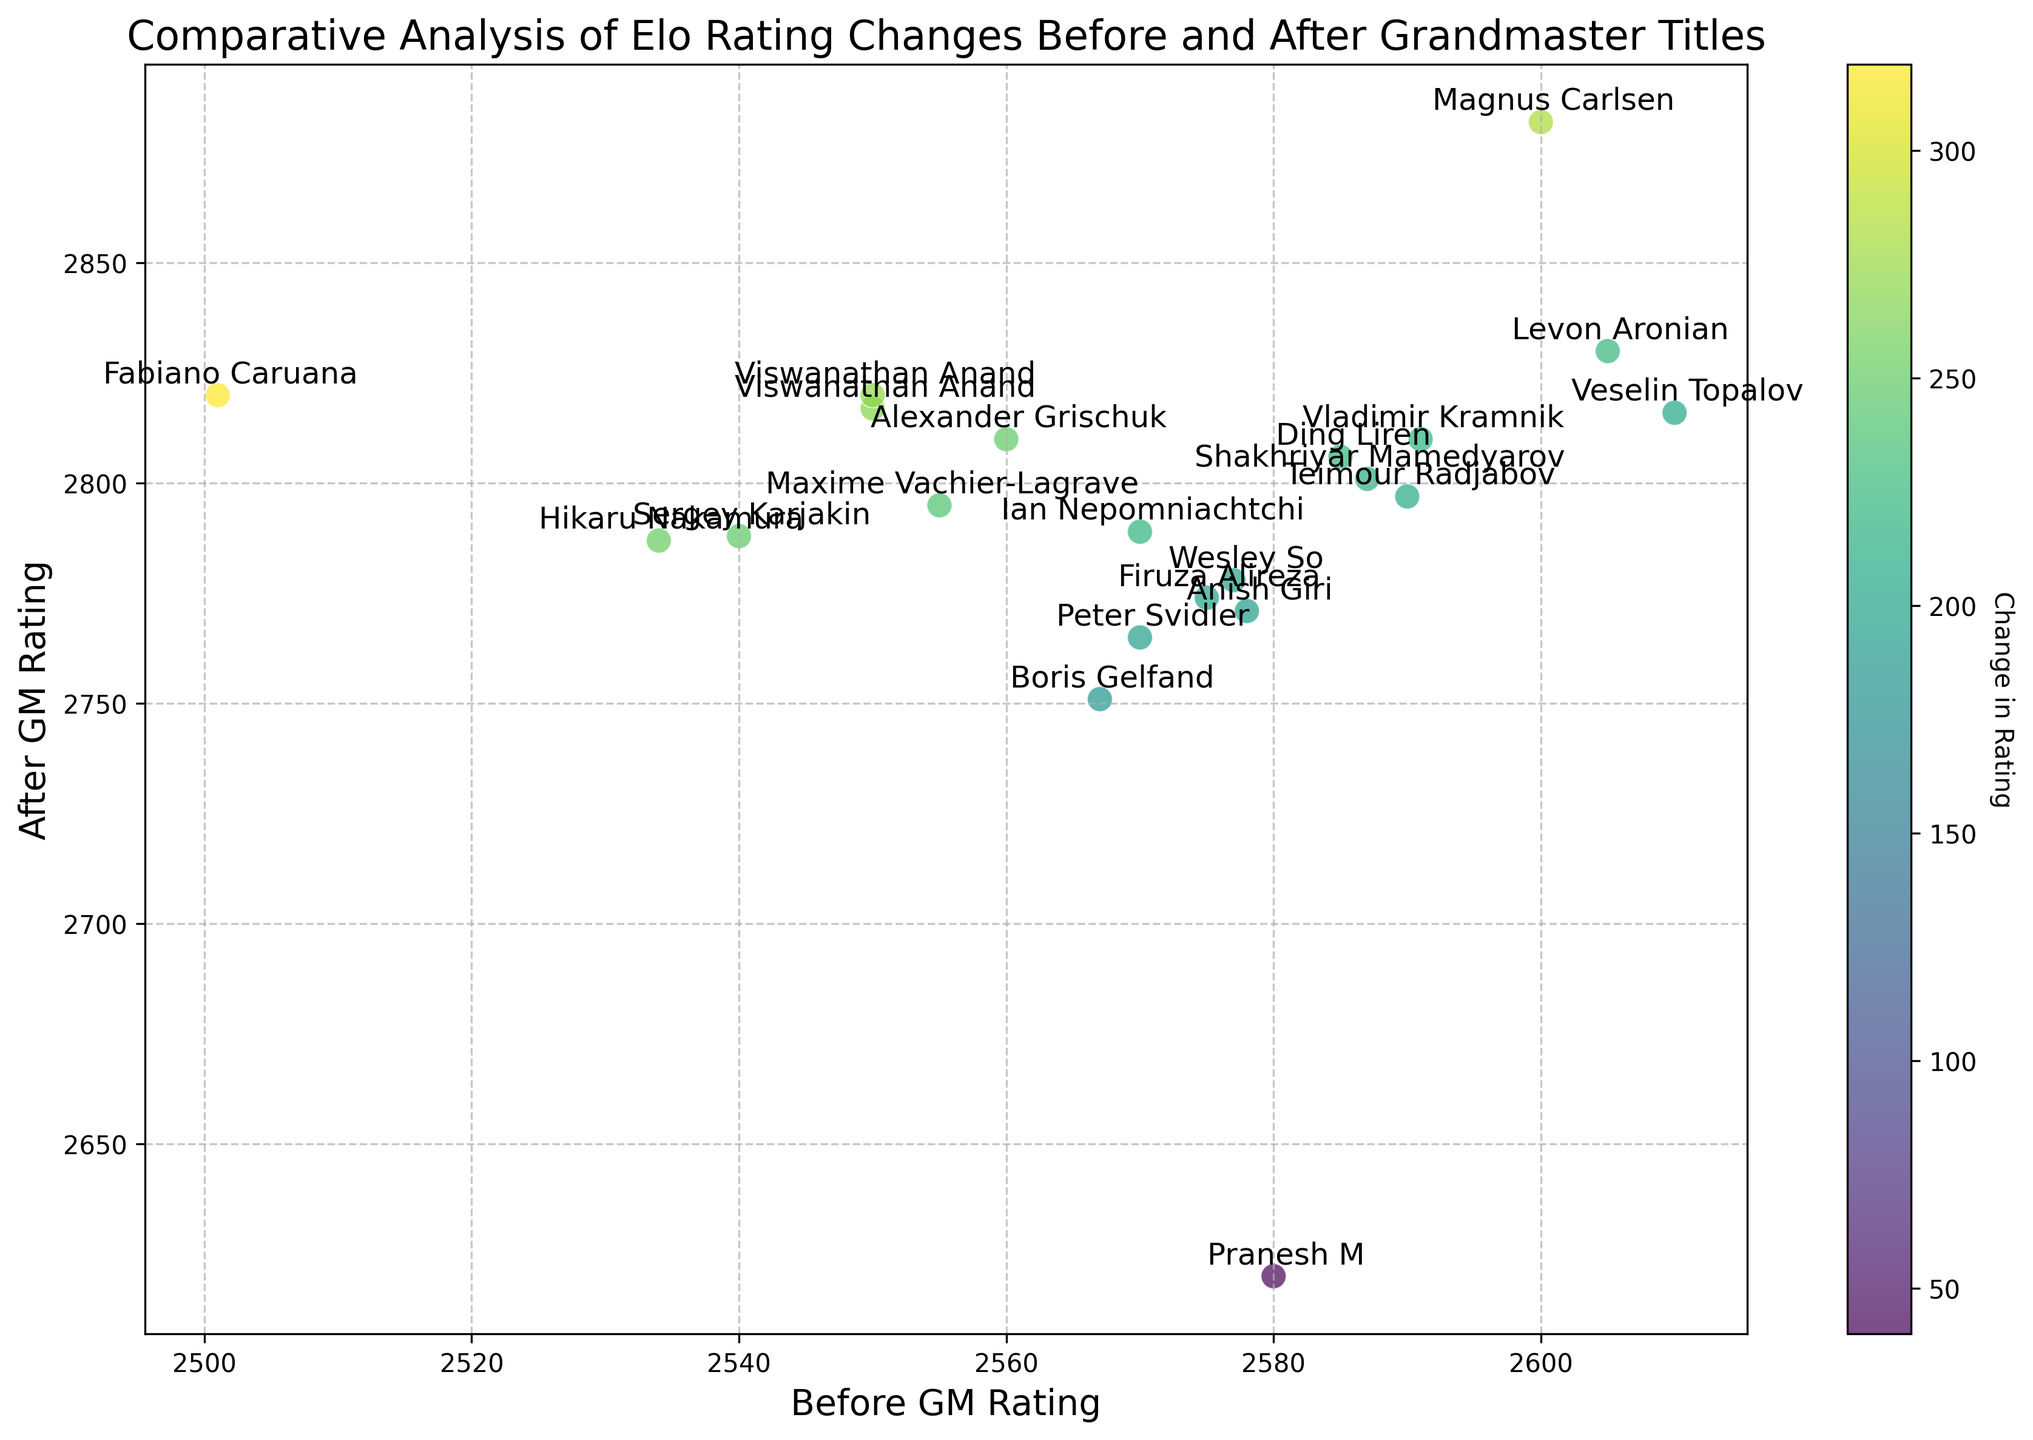Which player had the highest increase in Elo rating after becoming a Grandmaster? By observing the scatter plot, the color and annotation associated with the highest change in rating indicate that Fabiano Caruana had the highest increase in Elo rating after receiving the Grandmaster title.
Answer: Fabiano Caruana What's the average increase in Elo rating for the players shown? sum all the "Change in Rating" values: (40 + 282 + 267 + 253 + 319 + 201 + 219 + 221 + 193 + 225 + 248 + 207 + 250 + 240 + 214 + 195 + 184 + 270 + 219 + 199 + 206) = 4653. Then divide by the number of players, which is 21: 4653 / 21 ≈ 221.57
Answer: 221.57 Which player had the lowest rating before becoming a Grandmaster among all the players in the figure? The scatter plot annotations indicate the player's name at each data point. Identifying the point with the lowest x-value (Before GM Rating) shows that Fabiano Caruana had the rating of 2501
Answer: Fabiano Caruana Is the change in rating for Pranesh M below or above the average change in rating? Calculate the average change in rating, as done previously (221.57). Pranesh M's change in rating is shown by the color associated with his point, which is 40. Compare 40 to 221.57: 40 < 221.57
Answer: Below For two players with similar before and after ratings, who had a greater change in Elo rating, Viswanathan Anand or Wesley So? By checking the annotations and colors of their points on the scatter plot, Viswanathan Anand had more significant increments (identified by a higher change in color intensity) than Wesley So. Viswanathan Anand had a change of 267 and Wesley So of 201
Answer: Viswanathan Anand What's the total number of players whose increase in Elo rating is greater than 250? Visibly count the number of data points where the color intensity (associated with the "Change in Rating") exceeds 250: Magnus Carlsen (282), Viswanathan Anand (267), Hikaru Nakamura (253), and Fabiano Caruana (319)
Answer: 4 Does a higher "Before GM Rating" necessarily lead to a higher "After GM Rating"? By examining multiple points, we notice that there are anomalies where players with lower initial ratings achieve higher ratings post-GM compared to those with higher initial values. For example, Magnus Carlsen’s higher post-GM rating over Vladimir Kramnik despite a lower starting rating indicates it’s not necessarily true.
Answer: No Do Anish Giri and Ian Nepomniachtchi have a similar change in their Elo ratings? Check the annotations and colors associated with their points to compare their change in rating visually. Ian Nepomniachtchi’s change is 219 whereas Anish Giri’s change is 193. Their changes are relatively close in comparison to other players.
Answer: Yes Does Peter Svidler or Boris Gelfand have a higher "After GM Rating"? Comparing the y-values (After GM Rating) for both points, Peter Svidler has a rating of 2765 while Boris Gelfand has 2751. Thus, Peter Svidler has a higher rating.
Answer: Peter Svidler Who improved more between Ding Liren and Maxime Vachier-Lagrave? Identify their points through the annotations and color intensity. Compare the "After GM Rating" - "Before GM Rating" for both. Ding Liren's change: 221 and Maxime Vachier-Lagrave's change: 240, so Maxime improved more.
Answer: Maxime Vachier-Lagrave 